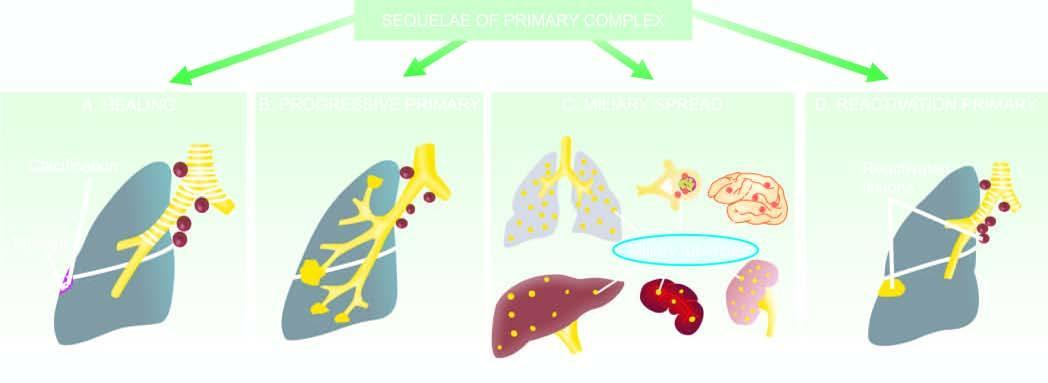what spread to lungs, liver, spleen, kidneys and brain?
Answer the question using a single word or phrase. Miliary 